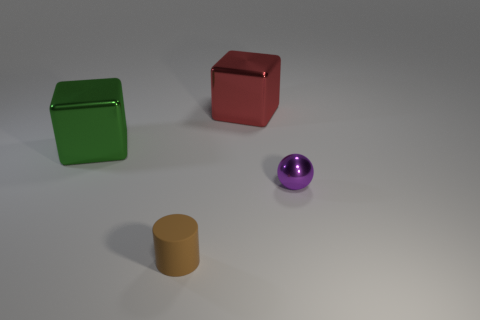What number of red things have the same size as the sphere?
Provide a short and direct response. 0. What shape is the tiny thing left of the shiny object that is on the right side of the large red thing?
Your answer should be very brief. Cylinder. Is the number of large yellow metallic cylinders less than the number of large green shiny things?
Offer a terse response. Yes. What is the color of the small object in front of the tiny shiny sphere?
Make the answer very short. Brown. The object that is both left of the large red metallic block and in front of the large green metallic block is made of what material?
Make the answer very short. Rubber. There is a big object that is made of the same material as the large red cube; what shape is it?
Your response must be concise. Cube. How many metal cubes are on the left side of the green cube that is left of the brown cylinder?
Provide a short and direct response. 0. What number of objects are both on the left side of the large red thing and behind the small brown cylinder?
Provide a succinct answer. 1. How many other things are made of the same material as the small cylinder?
Keep it short and to the point. 0. There is a cube on the right side of the tiny object that is left of the purple object; what color is it?
Keep it short and to the point. Red. 